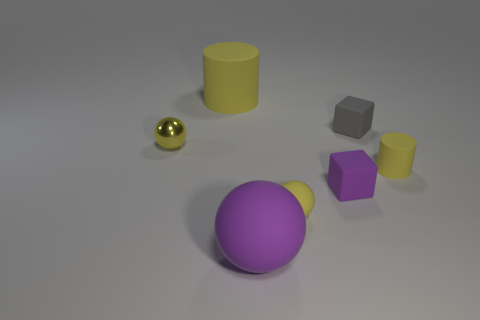Subtract all green cylinders. How many yellow balls are left? 2 Subtract all rubber balls. How many balls are left? 1 Add 2 matte cylinders. How many objects exist? 9 Subtract 1 yellow cylinders. How many objects are left? 6 Subtract all balls. How many objects are left? 4 Subtract all big matte cylinders. Subtract all cylinders. How many objects are left? 4 Add 7 large yellow things. How many large yellow things are left? 8 Add 4 large green matte spheres. How many large green matte spheres exist? 4 